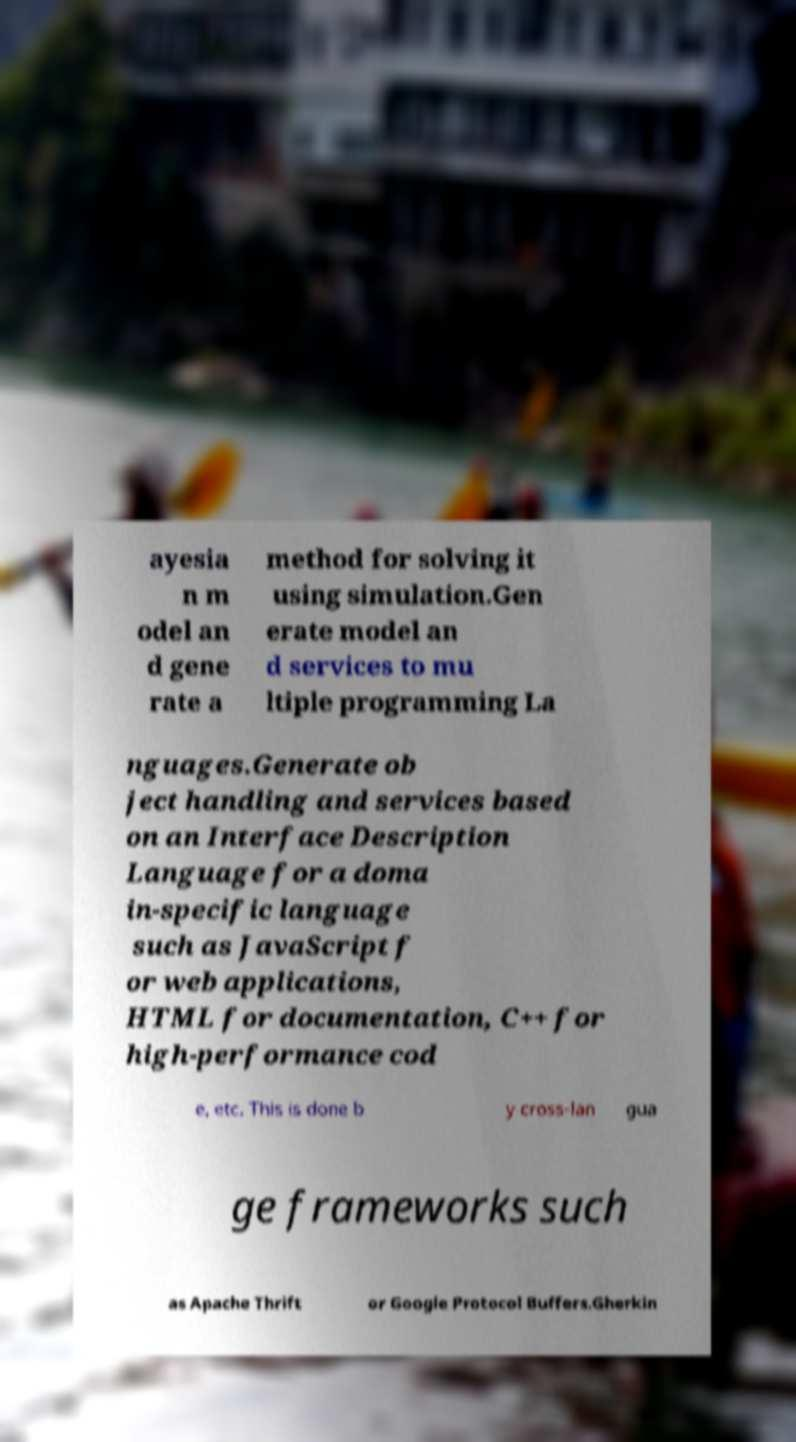Please read and relay the text visible in this image. What does it say? ayesia n m odel an d gene rate a method for solving it using simulation.Gen erate model an d services to mu ltiple programming La nguages.Generate ob ject handling and services based on an Interface Description Language for a doma in-specific language such as JavaScript f or web applications, HTML for documentation, C++ for high-performance cod e, etc. This is done b y cross-lan gua ge frameworks such as Apache Thrift or Google Protocol Buffers.Gherkin 